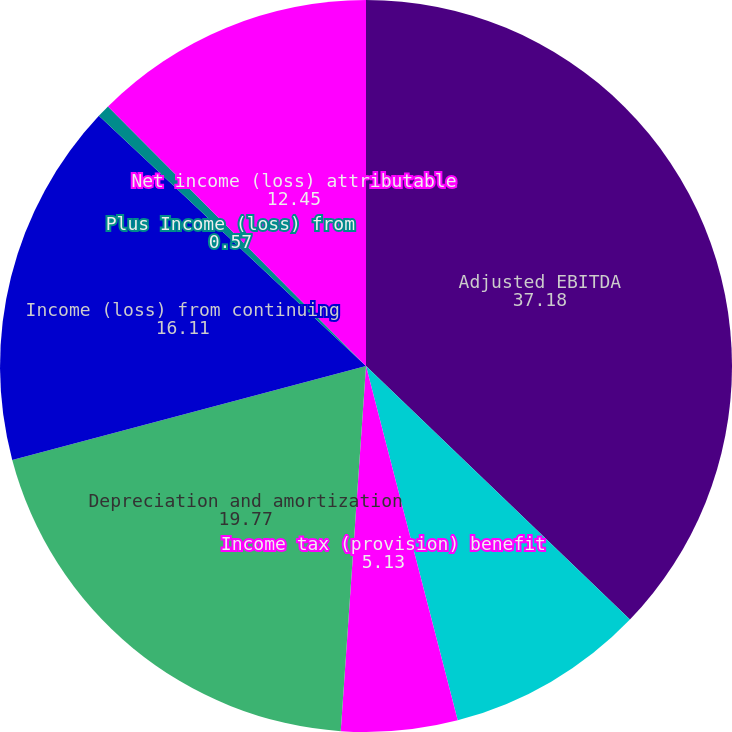<chart> <loc_0><loc_0><loc_500><loc_500><pie_chart><fcel>Adjusted EBITDA<fcel>Interest expense net<fcel>Income tax (provision) benefit<fcel>Depreciation and amortization<fcel>Income (loss) from continuing<fcel>Plus Income (loss) from<fcel>Net income (loss) attributable<nl><fcel>37.18%<fcel>8.79%<fcel>5.13%<fcel>19.77%<fcel>16.11%<fcel>0.57%<fcel>12.45%<nl></chart> 